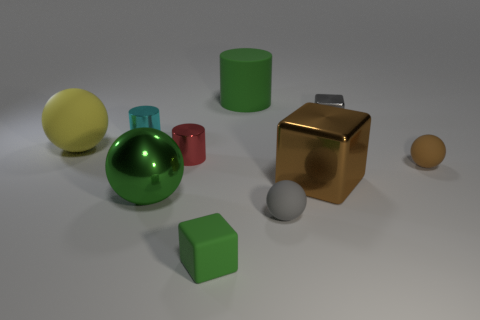Is the material of the big yellow object the same as the brown block? no 